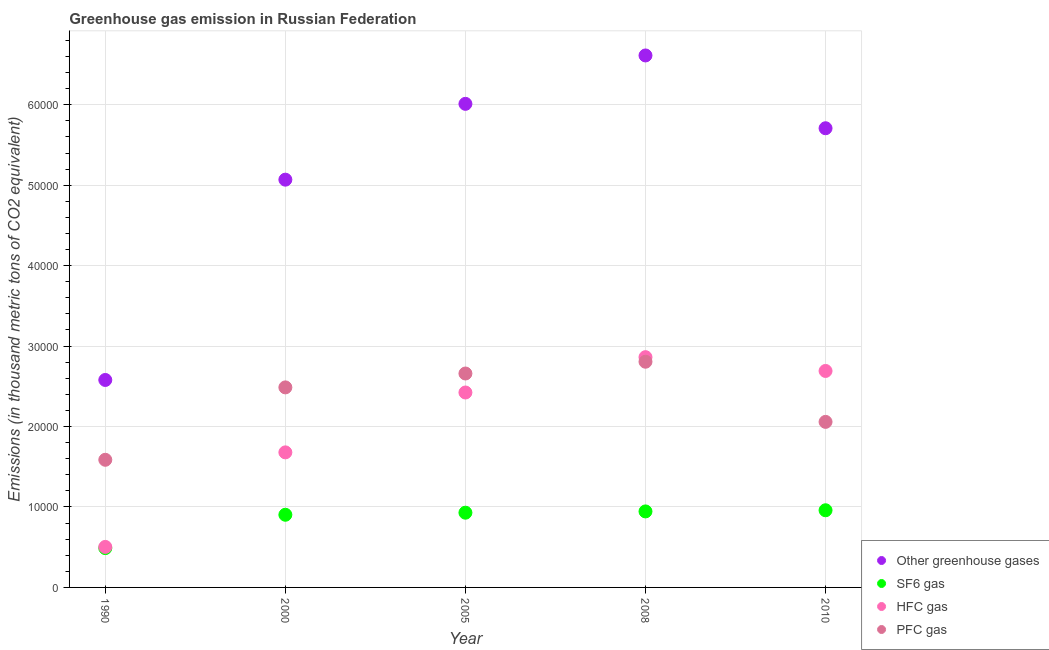Is the number of dotlines equal to the number of legend labels?
Your answer should be very brief. Yes. What is the emission of greenhouse gases in 2008?
Provide a short and direct response. 6.61e+04. Across all years, what is the maximum emission of pfc gas?
Your response must be concise. 2.81e+04. Across all years, what is the minimum emission of pfc gas?
Make the answer very short. 1.59e+04. In which year was the emission of pfc gas minimum?
Provide a succinct answer. 1990. What is the total emission of hfc gas in the graph?
Ensure brevity in your answer.  1.02e+05. What is the difference between the emission of hfc gas in 1990 and that in 2000?
Offer a terse response. -1.18e+04. What is the difference between the emission of greenhouse gases in 1990 and the emission of pfc gas in 2000?
Offer a very short reply. 922.5. What is the average emission of greenhouse gases per year?
Offer a very short reply. 5.20e+04. In the year 1990, what is the difference between the emission of sf6 gas and emission of pfc gas?
Ensure brevity in your answer.  -1.10e+04. In how many years, is the emission of pfc gas greater than 34000 thousand metric tons?
Your answer should be compact. 0. What is the ratio of the emission of greenhouse gases in 1990 to that in 2008?
Ensure brevity in your answer.  0.39. Is the difference between the emission of pfc gas in 2000 and 2010 greater than the difference between the emission of sf6 gas in 2000 and 2010?
Give a very brief answer. Yes. What is the difference between the highest and the second highest emission of hfc gas?
Keep it short and to the point. 1714.5. What is the difference between the highest and the lowest emission of hfc gas?
Ensure brevity in your answer.  2.36e+04. In how many years, is the emission of sf6 gas greater than the average emission of sf6 gas taken over all years?
Offer a very short reply. 4. Is it the case that in every year, the sum of the emission of greenhouse gases and emission of sf6 gas is greater than the emission of hfc gas?
Offer a very short reply. Yes. Is the emission of greenhouse gases strictly greater than the emission of pfc gas over the years?
Make the answer very short. Yes. How many dotlines are there?
Give a very brief answer. 4. How many years are there in the graph?
Make the answer very short. 5. What is the difference between two consecutive major ticks on the Y-axis?
Your response must be concise. 10000. Are the values on the major ticks of Y-axis written in scientific E-notation?
Keep it short and to the point. No. Does the graph contain grids?
Offer a very short reply. Yes. How many legend labels are there?
Your answer should be compact. 4. How are the legend labels stacked?
Keep it short and to the point. Vertical. What is the title of the graph?
Offer a terse response. Greenhouse gas emission in Russian Federation. Does "Secondary vocational" appear as one of the legend labels in the graph?
Make the answer very short. No. What is the label or title of the X-axis?
Keep it short and to the point. Year. What is the label or title of the Y-axis?
Give a very brief answer. Emissions (in thousand metric tons of CO2 equivalent). What is the Emissions (in thousand metric tons of CO2 equivalent) in Other greenhouse gases in 1990?
Give a very brief answer. 2.58e+04. What is the Emissions (in thousand metric tons of CO2 equivalent) in SF6 gas in 1990?
Provide a short and direct response. 4886.8. What is the Emissions (in thousand metric tons of CO2 equivalent) of HFC gas in 1990?
Provide a short and direct response. 5035.6. What is the Emissions (in thousand metric tons of CO2 equivalent) of PFC gas in 1990?
Offer a very short reply. 1.59e+04. What is the Emissions (in thousand metric tons of CO2 equivalent) in Other greenhouse gases in 2000?
Give a very brief answer. 5.07e+04. What is the Emissions (in thousand metric tons of CO2 equivalent) of SF6 gas in 2000?
Give a very brief answer. 9033.2. What is the Emissions (in thousand metric tons of CO2 equivalent) of HFC gas in 2000?
Make the answer very short. 1.68e+04. What is the Emissions (in thousand metric tons of CO2 equivalent) of PFC gas in 2000?
Offer a terse response. 2.49e+04. What is the Emissions (in thousand metric tons of CO2 equivalent) in Other greenhouse gases in 2005?
Your answer should be very brief. 6.01e+04. What is the Emissions (in thousand metric tons of CO2 equivalent) of SF6 gas in 2005?
Offer a terse response. 9289.9. What is the Emissions (in thousand metric tons of CO2 equivalent) in HFC gas in 2005?
Your answer should be very brief. 2.42e+04. What is the Emissions (in thousand metric tons of CO2 equivalent) in PFC gas in 2005?
Your answer should be compact. 2.66e+04. What is the Emissions (in thousand metric tons of CO2 equivalent) in Other greenhouse gases in 2008?
Provide a succinct answer. 6.61e+04. What is the Emissions (in thousand metric tons of CO2 equivalent) in SF6 gas in 2008?
Provide a short and direct response. 9448.2. What is the Emissions (in thousand metric tons of CO2 equivalent) of HFC gas in 2008?
Ensure brevity in your answer.  2.86e+04. What is the Emissions (in thousand metric tons of CO2 equivalent) in PFC gas in 2008?
Offer a terse response. 2.81e+04. What is the Emissions (in thousand metric tons of CO2 equivalent) of Other greenhouse gases in 2010?
Give a very brief answer. 5.71e+04. What is the Emissions (in thousand metric tons of CO2 equivalent) of SF6 gas in 2010?
Your response must be concise. 9592. What is the Emissions (in thousand metric tons of CO2 equivalent) in HFC gas in 2010?
Your answer should be very brief. 2.69e+04. What is the Emissions (in thousand metric tons of CO2 equivalent) in PFC gas in 2010?
Keep it short and to the point. 2.06e+04. Across all years, what is the maximum Emissions (in thousand metric tons of CO2 equivalent) in Other greenhouse gases?
Keep it short and to the point. 6.61e+04. Across all years, what is the maximum Emissions (in thousand metric tons of CO2 equivalent) in SF6 gas?
Your answer should be very brief. 9592. Across all years, what is the maximum Emissions (in thousand metric tons of CO2 equivalent) of HFC gas?
Give a very brief answer. 2.86e+04. Across all years, what is the maximum Emissions (in thousand metric tons of CO2 equivalent) in PFC gas?
Offer a terse response. 2.81e+04. Across all years, what is the minimum Emissions (in thousand metric tons of CO2 equivalent) of Other greenhouse gases?
Provide a short and direct response. 2.58e+04. Across all years, what is the minimum Emissions (in thousand metric tons of CO2 equivalent) of SF6 gas?
Provide a succinct answer. 4886.8. Across all years, what is the minimum Emissions (in thousand metric tons of CO2 equivalent) in HFC gas?
Offer a terse response. 5035.6. Across all years, what is the minimum Emissions (in thousand metric tons of CO2 equivalent) of PFC gas?
Make the answer very short. 1.59e+04. What is the total Emissions (in thousand metric tons of CO2 equivalent) in Other greenhouse gases in the graph?
Offer a terse response. 2.60e+05. What is the total Emissions (in thousand metric tons of CO2 equivalent) in SF6 gas in the graph?
Provide a short and direct response. 4.23e+04. What is the total Emissions (in thousand metric tons of CO2 equivalent) in HFC gas in the graph?
Ensure brevity in your answer.  1.02e+05. What is the total Emissions (in thousand metric tons of CO2 equivalent) in PFC gas in the graph?
Provide a short and direct response. 1.16e+05. What is the difference between the Emissions (in thousand metric tons of CO2 equivalent) of Other greenhouse gases in 1990 and that in 2000?
Ensure brevity in your answer.  -2.49e+04. What is the difference between the Emissions (in thousand metric tons of CO2 equivalent) in SF6 gas in 1990 and that in 2000?
Provide a succinct answer. -4146.4. What is the difference between the Emissions (in thousand metric tons of CO2 equivalent) of HFC gas in 1990 and that in 2000?
Ensure brevity in your answer.  -1.18e+04. What is the difference between the Emissions (in thousand metric tons of CO2 equivalent) of PFC gas in 1990 and that in 2000?
Your answer should be compact. -8999.9. What is the difference between the Emissions (in thousand metric tons of CO2 equivalent) of Other greenhouse gases in 1990 and that in 2005?
Keep it short and to the point. -3.43e+04. What is the difference between the Emissions (in thousand metric tons of CO2 equivalent) of SF6 gas in 1990 and that in 2005?
Provide a short and direct response. -4403.1. What is the difference between the Emissions (in thousand metric tons of CO2 equivalent) of HFC gas in 1990 and that in 2005?
Your answer should be compact. -1.92e+04. What is the difference between the Emissions (in thousand metric tons of CO2 equivalent) of PFC gas in 1990 and that in 2005?
Your response must be concise. -1.07e+04. What is the difference between the Emissions (in thousand metric tons of CO2 equivalent) of Other greenhouse gases in 1990 and that in 2008?
Make the answer very short. -4.03e+04. What is the difference between the Emissions (in thousand metric tons of CO2 equivalent) of SF6 gas in 1990 and that in 2008?
Ensure brevity in your answer.  -4561.4. What is the difference between the Emissions (in thousand metric tons of CO2 equivalent) of HFC gas in 1990 and that in 2008?
Offer a terse response. -2.36e+04. What is the difference between the Emissions (in thousand metric tons of CO2 equivalent) of PFC gas in 1990 and that in 2008?
Your answer should be compact. -1.22e+04. What is the difference between the Emissions (in thousand metric tons of CO2 equivalent) in Other greenhouse gases in 1990 and that in 2010?
Ensure brevity in your answer.  -3.13e+04. What is the difference between the Emissions (in thousand metric tons of CO2 equivalent) of SF6 gas in 1990 and that in 2010?
Your response must be concise. -4705.2. What is the difference between the Emissions (in thousand metric tons of CO2 equivalent) of HFC gas in 1990 and that in 2010?
Your answer should be compact. -2.19e+04. What is the difference between the Emissions (in thousand metric tons of CO2 equivalent) in PFC gas in 1990 and that in 2010?
Keep it short and to the point. -4711.8. What is the difference between the Emissions (in thousand metric tons of CO2 equivalent) in Other greenhouse gases in 2000 and that in 2005?
Your answer should be compact. -9424.5. What is the difference between the Emissions (in thousand metric tons of CO2 equivalent) in SF6 gas in 2000 and that in 2005?
Your answer should be very brief. -256.7. What is the difference between the Emissions (in thousand metric tons of CO2 equivalent) of HFC gas in 2000 and that in 2005?
Provide a succinct answer. -7442.6. What is the difference between the Emissions (in thousand metric tons of CO2 equivalent) of PFC gas in 2000 and that in 2005?
Your answer should be very brief. -1725.2. What is the difference between the Emissions (in thousand metric tons of CO2 equivalent) in Other greenhouse gases in 2000 and that in 2008?
Offer a very short reply. -1.54e+04. What is the difference between the Emissions (in thousand metric tons of CO2 equivalent) of SF6 gas in 2000 and that in 2008?
Your answer should be very brief. -415. What is the difference between the Emissions (in thousand metric tons of CO2 equivalent) in HFC gas in 2000 and that in 2008?
Provide a succinct answer. -1.18e+04. What is the difference between the Emissions (in thousand metric tons of CO2 equivalent) of PFC gas in 2000 and that in 2008?
Ensure brevity in your answer.  -3189.7. What is the difference between the Emissions (in thousand metric tons of CO2 equivalent) of Other greenhouse gases in 2000 and that in 2010?
Give a very brief answer. -6391. What is the difference between the Emissions (in thousand metric tons of CO2 equivalent) in SF6 gas in 2000 and that in 2010?
Offer a very short reply. -558.8. What is the difference between the Emissions (in thousand metric tons of CO2 equivalent) of HFC gas in 2000 and that in 2010?
Offer a terse response. -1.01e+04. What is the difference between the Emissions (in thousand metric tons of CO2 equivalent) in PFC gas in 2000 and that in 2010?
Provide a short and direct response. 4288.1. What is the difference between the Emissions (in thousand metric tons of CO2 equivalent) in Other greenhouse gases in 2005 and that in 2008?
Offer a terse response. -6015. What is the difference between the Emissions (in thousand metric tons of CO2 equivalent) in SF6 gas in 2005 and that in 2008?
Give a very brief answer. -158.3. What is the difference between the Emissions (in thousand metric tons of CO2 equivalent) in HFC gas in 2005 and that in 2008?
Offer a terse response. -4392.2. What is the difference between the Emissions (in thousand metric tons of CO2 equivalent) in PFC gas in 2005 and that in 2008?
Ensure brevity in your answer.  -1464.5. What is the difference between the Emissions (in thousand metric tons of CO2 equivalent) in Other greenhouse gases in 2005 and that in 2010?
Give a very brief answer. 3033.5. What is the difference between the Emissions (in thousand metric tons of CO2 equivalent) of SF6 gas in 2005 and that in 2010?
Make the answer very short. -302.1. What is the difference between the Emissions (in thousand metric tons of CO2 equivalent) in HFC gas in 2005 and that in 2010?
Your answer should be compact. -2677.7. What is the difference between the Emissions (in thousand metric tons of CO2 equivalent) in PFC gas in 2005 and that in 2010?
Give a very brief answer. 6013.3. What is the difference between the Emissions (in thousand metric tons of CO2 equivalent) of Other greenhouse gases in 2008 and that in 2010?
Your answer should be compact. 9048.5. What is the difference between the Emissions (in thousand metric tons of CO2 equivalent) of SF6 gas in 2008 and that in 2010?
Give a very brief answer. -143.8. What is the difference between the Emissions (in thousand metric tons of CO2 equivalent) of HFC gas in 2008 and that in 2010?
Provide a short and direct response. 1714.5. What is the difference between the Emissions (in thousand metric tons of CO2 equivalent) of PFC gas in 2008 and that in 2010?
Offer a very short reply. 7477.8. What is the difference between the Emissions (in thousand metric tons of CO2 equivalent) of Other greenhouse gases in 1990 and the Emissions (in thousand metric tons of CO2 equivalent) of SF6 gas in 2000?
Give a very brief answer. 1.68e+04. What is the difference between the Emissions (in thousand metric tons of CO2 equivalent) in Other greenhouse gases in 1990 and the Emissions (in thousand metric tons of CO2 equivalent) in HFC gas in 2000?
Make the answer very short. 8999.9. What is the difference between the Emissions (in thousand metric tons of CO2 equivalent) in Other greenhouse gases in 1990 and the Emissions (in thousand metric tons of CO2 equivalent) in PFC gas in 2000?
Ensure brevity in your answer.  922.5. What is the difference between the Emissions (in thousand metric tons of CO2 equivalent) in SF6 gas in 1990 and the Emissions (in thousand metric tons of CO2 equivalent) in HFC gas in 2000?
Offer a terse response. -1.19e+04. What is the difference between the Emissions (in thousand metric tons of CO2 equivalent) of SF6 gas in 1990 and the Emissions (in thousand metric tons of CO2 equivalent) of PFC gas in 2000?
Give a very brief answer. -2.00e+04. What is the difference between the Emissions (in thousand metric tons of CO2 equivalent) in HFC gas in 1990 and the Emissions (in thousand metric tons of CO2 equivalent) in PFC gas in 2000?
Ensure brevity in your answer.  -1.98e+04. What is the difference between the Emissions (in thousand metric tons of CO2 equivalent) of Other greenhouse gases in 1990 and the Emissions (in thousand metric tons of CO2 equivalent) of SF6 gas in 2005?
Ensure brevity in your answer.  1.65e+04. What is the difference between the Emissions (in thousand metric tons of CO2 equivalent) of Other greenhouse gases in 1990 and the Emissions (in thousand metric tons of CO2 equivalent) of HFC gas in 2005?
Give a very brief answer. 1557.3. What is the difference between the Emissions (in thousand metric tons of CO2 equivalent) in Other greenhouse gases in 1990 and the Emissions (in thousand metric tons of CO2 equivalent) in PFC gas in 2005?
Make the answer very short. -802.7. What is the difference between the Emissions (in thousand metric tons of CO2 equivalent) in SF6 gas in 1990 and the Emissions (in thousand metric tons of CO2 equivalent) in HFC gas in 2005?
Offer a very short reply. -1.93e+04. What is the difference between the Emissions (in thousand metric tons of CO2 equivalent) of SF6 gas in 1990 and the Emissions (in thousand metric tons of CO2 equivalent) of PFC gas in 2005?
Provide a short and direct response. -2.17e+04. What is the difference between the Emissions (in thousand metric tons of CO2 equivalent) in HFC gas in 1990 and the Emissions (in thousand metric tons of CO2 equivalent) in PFC gas in 2005?
Give a very brief answer. -2.16e+04. What is the difference between the Emissions (in thousand metric tons of CO2 equivalent) of Other greenhouse gases in 1990 and the Emissions (in thousand metric tons of CO2 equivalent) of SF6 gas in 2008?
Provide a succinct answer. 1.63e+04. What is the difference between the Emissions (in thousand metric tons of CO2 equivalent) of Other greenhouse gases in 1990 and the Emissions (in thousand metric tons of CO2 equivalent) of HFC gas in 2008?
Give a very brief answer. -2834.9. What is the difference between the Emissions (in thousand metric tons of CO2 equivalent) in Other greenhouse gases in 1990 and the Emissions (in thousand metric tons of CO2 equivalent) in PFC gas in 2008?
Keep it short and to the point. -2267.2. What is the difference between the Emissions (in thousand metric tons of CO2 equivalent) in SF6 gas in 1990 and the Emissions (in thousand metric tons of CO2 equivalent) in HFC gas in 2008?
Provide a succinct answer. -2.37e+04. What is the difference between the Emissions (in thousand metric tons of CO2 equivalent) of SF6 gas in 1990 and the Emissions (in thousand metric tons of CO2 equivalent) of PFC gas in 2008?
Make the answer very short. -2.32e+04. What is the difference between the Emissions (in thousand metric tons of CO2 equivalent) of HFC gas in 1990 and the Emissions (in thousand metric tons of CO2 equivalent) of PFC gas in 2008?
Ensure brevity in your answer.  -2.30e+04. What is the difference between the Emissions (in thousand metric tons of CO2 equivalent) of Other greenhouse gases in 1990 and the Emissions (in thousand metric tons of CO2 equivalent) of SF6 gas in 2010?
Ensure brevity in your answer.  1.62e+04. What is the difference between the Emissions (in thousand metric tons of CO2 equivalent) of Other greenhouse gases in 1990 and the Emissions (in thousand metric tons of CO2 equivalent) of HFC gas in 2010?
Your response must be concise. -1120.4. What is the difference between the Emissions (in thousand metric tons of CO2 equivalent) in Other greenhouse gases in 1990 and the Emissions (in thousand metric tons of CO2 equivalent) in PFC gas in 2010?
Ensure brevity in your answer.  5210.6. What is the difference between the Emissions (in thousand metric tons of CO2 equivalent) of SF6 gas in 1990 and the Emissions (in thousand metric tons of CO2 equivalent) of HFC gas in 2010?
Ensure brevity in your answer.  -2.20e+04. What is the difference between the Emissions (in thousand metric tons of CO2 equivalent) in SF6 gas in 1990 and the Emissions (in thousand metric tons of CO2 equivalent) in PFC gas in 2010?
Your answer should be very brief. -1.57e+04. What is the difference between the Emissions (in thousand metric tons of CO2 equivalent) in HFC gas in 1990 and the Emissions (in thousand metric tons of CO2 equivalent) in PFC gas in 2010?
Your answer should be compact. -1.55e+04. What is the difference between the Emissions (in thousand metric tons of CO2 equivalent) of Other greenhouse gases in 2000 and the Emissions (in thousand metric tons of CO2 equivalent) of SF6 gas in 2005?
Ensure brevity in your answer.  4.14e+04. What is the difference between the Emissions (in thousand metric tons of CO2 equivalent) in Other greenhouse gases in 2000 and the Emissions (in thousand metric tons of CO2 equivalent) in HFC gas in 2005?
Keep it short and to the point. 2.65e+04. What is the difference between the Emissions (in thousand metric tons of CO2 equivalent) in Other greenhouse gases in 2000 and the Emissions (in thousand metric tons of CO2 equivalent) in PFC gas in 2005?
Offer a very short reply. 2.41e+04. What is the difference between the Emissions (in thousand metric tons of CO2 equivalent) in SF6 gas in 2000 and the Emissions (in thousand metric tons of CO2 equivalent) in HFC gas in 2005?
Keep it short and to the point. -1.52e+04. What is the difference between the Emissions (in thousand metric tons of CO2 equivalent) of SF6 gas in 2000 and the Emissions (in thousand metric tons of CO2 equivalent) of PFC gas in 2005?
Your answer should be compact. -1.76e+04. What is the difference between the Emissions (in thousand metric tons of CO2 equivalent) of HFC gas in 2000 and the Emissions (in thousand metric tons of CO2 equivalent) of PFC gas in 2005?
Your response must be concise. -9802.6. What is the difference between the Emissions (in thousand metric tons of CO2 equivalent) of Other greenhouse gases in 2000 and the Emissions (in thousand metric tons of CO2 equivalent) of SF6 gas in 2008?
Provide a succinct answer. 4.12e+04. What is the difference between the Emissions (in thousand metric tons of CO2 equivalent) of Other greenhouse gases in 2000 and the Emissions (in thousand metric tons of CO2 equivalent) of HFC gas in 2008?
Make the answer very short. 2.21e+04. What is the difference between the Emissions (in thousand metric tons of CO2 equivalent) of Other greenhouse gases in 2000 and the Emissions (in thousand metric tons of CO2 equivalent) of PFC gas in 2008?
Keep it short and to the point. 2.26e+04. What is the difference between the Emissions (in thousand metric tons of CO2 equivalent) in SF6 gas in 2000 and the Emissions (in thousand metric tons of CO2 equivalent) in HFC gas in 2008?
Your answer should be compact. -1.96e+04. What is the difference between the Emissions (in thousand metric tons of CO2 equivalent) in SF6 gas in 2000 and the Emissions (in thousand metric tons of CO2 equivalent) in PFC gas in 2008?
Your answer should be compact. -1.90e+04. What is the difference between the Emissions (in thousand metric tons of CO2 equivalent) of HFC gas in 2000 and the Emissions (in thousand metric tons of CO2 equivalent) of PFC gas in 2008?
Offer a very short reply. -1.13e+04. What is the difference between the Emissions (in thousand metric tons of CO2 equivalent) of Other greenhouse gases in 2000 and the Emissions (in thousand metric tons of CO2 equivalent) of SF6 gas in 2010?
Your answer should be compact. 4.11e+04. What is the difference between the Emissions (in thousand metric tons of CO2 equivalent) of Other greenhouse gases in 2000 and the Emissions (in thousand metric tons of CO2 equivalent) of HFC gas in 2010?
Offer a terse response. 2.38e+04. What is the difference between the Emissions (in thousand metric tons of CO2 equivalent) of Other greenhouse gases in 2000 and the Emissions (in thousand metric tons of CO2 equivalent) of PFC gas in 2010?
Provide a short and direct response. 3.01e+04. What is the difference between the Emissions (in thousand metric tons of CO2 equivalent) in SF6 gas in 2000 and the Emissions (in thousand metric tons of CO2 equivalent) in HFC gas in 2010?
Provide a short and direct response. -1.79e+04. What is the difference between the Emissions (in thousand metric tons of CO2 equivalent) in SF6 gas in 2000 and the Emissions (in thousand metric tons of CO2 equivalent) in PFC gas in 2010?
Your answer should be very brief. -1.15e+04. What is the difference between the Emissions (in thousand metric tons of CO2 equivalent) in HFC gas in 2000 and the Emissions (in thousand metric tons of CO2 equivalent) in PFC gas in 2010?
Your response must be concise. -3789.3. What is the difference between the Emissions (in thousand metric tons of CO2 equivalent) of Other greenhouse gases in 2005 and the Emissions (in thousand metric tons of CO2 equivalent) of SF6 gas in 2008?
Give a very brief answer. 5.07e+04. What is the difference between the Emissions (in thousand metric tons of CO2 equivalent) of Other greenhouse gases in 2005 and the Emissions (in thousand metric tons of CO2 equivalent) of HFC gas in 2008?
Ensure brevity in your answer.  3.15e+04. What is the difference between the Emissions (in thousand metric tons of CO2 equivalent) in Other greenhouse gases in 2005 and the Emissions (in thousand metric tons of CO2 equivalent) in PFC gas in 2008?
Keep it short and to the point. 3.21e+04. What is the difference between the Emissions (in thousand metric tons of CO2 equivalent) in SF6 gas in 2005 and the Emissions (in thousand metric tons of CO2 equivalent) in HFC gas in 2008?
Give a very brief answer. -1.93e+04. What is the difference between the Emissions (in thousand metric tons of CO2 equivalent) of SF6 gas in 2005 and the Emissions (in thousand metric tons of CO2 equivalent) of PFC gas in 2008?
Your answer should be compact. -1.88e+04. What is the difference between the Emissions (in thousand metric tons of CO2 equivalent) in HFC gas in 2005 and the Emissions (in thousand metric tons of CO2 equivalent) in PFC gas in 2008?
Ensure brevity in your answer.  -3824.5. What is the difference between the Emissions (in thousand metric tons of CO2 equivalent) of Other greenhouse gases in 2005 and the Emissions (in thousand metric tons of CO2 equivalent) of SF6 gas in 2010?
Offer a very short reply. 5.05e+04. What is the difference between the Emissions (in thousand metric tons of CO2 equivalent) in Other greenhouse gases in 2005 and the Emissions (in thousand metric tons of CO2 equivalent) in HFC gas in 2010?
Your answer should be very brief. 3.32e+04. What is the difference between the Emissions (in thousand metric tons of CO2 equivalent) of Other greenhouse gases in 2005 and the Emissions (in thousand metric tons of CO2 equivalent) of PFC gas in 2010?
Your answer should be very brief. 3.95e+04. What is the difference between the Emissions (in thousand metric tons of CO2 equivalent) of SF6 gas in 2005 and the Emissions (in thousand metric tons of CO2 equivalent) of HFC gas in 2010?
Ensure brevity in your answer.  -1.76e+04. What is the difference between the Emissions (in thousand metric tons of CO2 equivalent) in SF6 gas in 2005 and the Emissions (in thousand metric tons of CO2 equivalent) in PFC gas in 2010?
Offer a terse response. -1.13e+04. What is the difference between the Emissions (in thousand metric tons of CO2 equivalent) of HFC gas in 2005 and the Emissions (in thousand metric tons of CO2 equivalent) of PFC gas in 2010?
Offer a very short reply. 3653.3. What is the difference between the Emissions (in thousand metric tons of CO2 equivalent) of Other greenhouse gases in 2008 and the Emissions (in thousand metric tons of CO2 equivalent) of SF6 gas in 2010?
Your response must be concise. 5.65e+04. What is the difference between the Emissions (in thousand metric tons of CO2 equivalent) in Other greenhouse gases in 2008 and the Emissions (in thousand metric tons of CO2 equivalent) in HFC gas in 2010?
Ensure brevity in your answer.  3.92e+04. What is the difference between the Emissions (in thousand metric tons of CO2 equivalent) in Other greenhouse gases in 2008 and the Emissions (in thousand metric tons of CO2 equivalent) in PFC gas in 2010?
Your answer should be compact. 4.55e+04. What is the difference between the Emissions (in thousand metric tons of CO2 equivalent) in SF6 gas in 2008 and the Emissions (in thousand metric tons of CO2 equivalent) in HFC gas in 2010?
Give a very brief answer. -1.75e+04. What is the difference between the Emissions (in thousand metric tons of CO2 equivalent) in SF6 gas in 2008 and the Emissions (in thousand metric tons of CO2 equivalent) in PFC gas in 2010?
Make the answer very short. -1.11e+04. What is the difference between the Emissions (in thousand metric tons of CO2 equivalent) of HFC gas in 2008 and the Emissions (in thousand metric tons of CO2 equivalent) of PFC gas in 2010?
Offer a very short reply. 8045.5. What is the average Emissions (in thousand metric tons of CO2 equivalent) in Other greenhouse gases per year?
Give a very brief answer. 5.20e+04. What is the average Emissions (in thousand metric tons of CO2 equivalent) of SF6 gas per year?
Provide a succinct answer. 8450.02. What is the average Emissions (in thousand metric tons of CO2 equivalent) of HFC gas per year?
Ensure brevity in your answer.  2.03e+04. What is the average Emissions (in thousand metric tons of CO2 equivalent) in PFC gas per year?
Provide a succinct answer. 2.32e+04. In the year 1990, what is the difference between the Emissions (in thousand metric tons of CO2 equivalent) in Other greenhouse gases and Emissions (in thousand metric tons of CO2 equivalent) in SF6 gas?
Ensure brevity in your answer.  2.09e+04. In the year 1990, what is the difference between the Emissions (in thousand metric tons of CO2 equivalent) of Other greenhouse gases and Emissions (in thousand metric tons of CO2 equivalent) of HFC gas?
Provide a short and direct response. 2.08e+04. In the year 1990, what is the difference between the Emissions (in thousand metric tons of CO2 equivalent) in Other greenhouse gases and Emissions (in thousand metric tons of CO2 equivalent) in PFC gas?
Provide a short and direct response. 9922.4. In the year 1990, what is the difference between the Emissions (in thousand metric tons of CO2 equivalent) in SF6 gas and Emissions (in thousand metric tons of CO2 equivalent) in HFC gas?
Provide a succinct answer. -148.8. In the year 1990, what is the difference between the Emissions (in thousand metric tons of CO2 equivalent) of SF6 gas and Emissions (in thousand metric tons of CO2 equivalent) of PFC gas?
Offer a very short reply. -1.10e+04. In the year 1990, what is the difference between the Emissions (in thousand metric tons of CO2 equivalent) of HFC gas and Emissions (in thousand metric tons of CO2 equivalent) of PFC gas?
Give a very brief answer. -1.08e+04. In the year 2000, what is the difference between the Emissions (in thousand metric tons of CO2 equivalent) of Other greenhouse gases and Emissions (in thousand metric tons of CO2 equivalent) of SF6 gas?
Your answer should be very brief. 4.17e+04. In the year 2000, what is the difference between the Emissions (in thousand metric tons of CO2 equivalent) in Other greenhouse gases and Emissions (in thousand metric tons of CO2 equivalent) in HFC gas?
Your answer should be very brief. 3.39e+04. In the year 2000, what is the difference between the Emissions (in thousand metric tons of CO2 equivalent) in Other greenhouse gases and Emissions (in thousand metric tons of CO2 equivalent) in PFC gas?
Keep it short and to the point. 2.58e+04. In the year 2000, what is the difference between the Emissions (in thousand metric tons of CO2 equivalent) of SF6 gas and Emissions (in thousand metric tons of CO2 equivalent) of HFC gas?
Make the answer very short. -7755.5. In the year 2000, what is the difference between the Emissions (in thousand metric tons of CO2 equivalent) of SF6 gas and Emissions (in thousand metric tons of CO2 equivalent) of PFC gas?
Provide a succinct answer. -1.58e+04. In the year 2000, what is the difference between the Emissions (in thousand metric tons of CO2 equivalent) of HFC gas and Emissions (in thousand metric tons of CO2 equivalent) of PFC gas?
Offer a terse response. -8077.4. In the year 2005, what is the difference between the Emissions (in thousand metric tons of CO2 equivalent) in Other greenhouse gases and Emissions (in thousand metric tons of CO2 equivalent) in SF6 gas?
Keep it short and to the point. 5.08e+04. In the year 2005, what is the difference between the Emissions (in thousand metric tons of CO2 equivalent) of Other greenhouse gases and Emissions (in thousand metric tons of CO2 equivalent) of HFC gas?
Your response must be concise. 3.59e+04. In the year 2005, what is the difference between the Emissions (in thousand metric tons of CO2 equivalent) in Other greenhouse gases and Emissions (in thousand metric tons of CO2 equivalent) in PFC gas?
Make the answer very short. 3.35e+04. In the year 2005, what is the difference between the Emissions (in thousand metric tons of CO2 equivalent) of SF6 gas and Emissions (in thousand metric tons of CO2 equivalent) of HFC gas?
Give a very brief answer. -1.49e+04. In the year 2005, what is the difference between the Emissions (in thousand metric tons of CO2 equivalent) of SF6 gas and Emissions (in thousand metric tons of CO2 equivalent) of PFC gas?
Give a very brief answer. -1.73e+04. In the year 2005, what is the difference between the Emissions (in thousand metric tons of CO2 equivalent) of HFC gas and Emissions (in thousand metric tons of CO2 equivalent) of PFC gas?
Ensure brevity in your answer.  -2360. In the year 2008, what is the difference between the Emissions (in thousand metric tons of CO2 equivalent) of Other greenhouse gases and Emissions (in thousand metric tons of CO2 equivalent) of SF6 gas?
Keep it short and to the point. 5.67e+04. In the year 2008, what is the difference between the Emissions (in thousand metric tons of CO2 equivalent) in Other greenhouse gases and Emissions (in thousand metric tons of CO2 equivalent) in HFC gas?
Give a very brief answer. 3.75e+04. In the year 2008, what is the difference between the Emissions (in thousand metric tons of CO2 equivalent) of Other greenhouse gases and Emissions (in thousand metric tons of CO2 equivalent) of PFC gas?
Keep it short and to the point. 3.81e+04. In the year 2008, what is the difference between the Emissions (in thousand metric tons of CO2 equivalent) in SF6 gas and Emissions (in thousand metric tons of CO2 equivalent) in HFC gas?
Your answer should be compact. -1.92e+04. In the year 2008, what is the difference between the Emissions (in thousand metric tons of CO2 equivalent) in SF6 gas and Emissions (in thousand metric tons of CO2 equivalent) in PFC gas?
Provide a short and direct response. -1.86e+04. In the year 2008, what is the difference between the Emissions (in thousand metric tons of CO2 equivalent) in HFC gas and Emissions (in thousand metric tons of CO2 equivalent) in PFC gas?
Offer a terse response. 567.7. In the year 2010, what is the difference between the Emissions (in thousand metric tons of CO2 equivalent) of Other greenhouse gases and Emissions (in thousand metric tons of CO2 equivalent) of SF6 gas?
Your answer should be compact. 4.75e+04. In the year 2010, what is the difference between the Emissions (in thousand metric tons of CO2 equivalent) of Other greenhouse gases and Emissions (in thousand metric tons of CO2 equivalent) of HFC gas?
Offer a terse response. 3.02e+04. In the year 2010, what is the difference between the Emissions (in thousand metric tons of CO2 equivalent) of Other greenhouse gases and Emissions (in thousand metric tons of CO2 equivalent) of PFC gas?
Your response must be concise. 3.65e+04. In the year 2010, what is the difference between the Emissions (in thousand metric tons of CO2 equivalent) of SF6 gas and Emissions (in thousand metric tons of CO2 equivalent) of HFC gas?
Give a very brief answer. -1.73e+04. In the year 2010, what is the difference between the Emissions (in thousand metric tons of CO2 equivalent) in SF6 gas and Emissions (in thousand metric tons of CO2 equivalent) in PFC gas?
Offer a terse response. -1.10e+04. In the year 2010, what is the difference between the Emissions (in thousand metric tons of CO2 equivalent) in HFC gas and Emissions (in thousand metric tons of CO2 equivalent) in PFC gas?
Make the answer very short. 6331. What is the ratio of the Emissions (in thousand metric tons of CO2 equivalent) in Other greenhouse gases in 1990 to that in 2000?
Offer a very short reply. 0.51. What is the ratio of the Emissions (in thousand metric tons of CO2 equivalent) in SF6 gas in 1990 to that in 2000?
Offer a very short reply. 0.54. What is the ratio of the Emissions (in thousand metric tons of CO2 equivalent) in HFC gas in 1990 to that in 2000?
Ensure brevity in your answer.  0.3. What is the ratio of the Emissions (in thousand metric tons of CO2 equivalent) of PFC gas in 1990 to that in 2000?
Your answer should be compact. 0.64. What is the ratio of the Emissions (in thousand metric tons of CO2 equivalent) of Other greenhouse gases in 1990 to that in 2005?
Give a very brief answer. 0.43. What is the ratio of the Emissions (in thousand metric tons of CO2 equivalent) of SF6 gas in 1990 to that in 2005?
Offer a very short reply. 0.53. What is the ratio of the Emissions (in thousand metric tons of CO2 equivalent) of HFC gas in 1990 to that in 2005?
Offer a terse response. 0.21. What is the ratio of the Emissions (in thousand metric tons of CO2 equivalent) in PFC gas in 1990 to that in 2005?
Provide a succinct answer. 0.6. What is the ratio of the Emissions (in thousand metric tons of CO2 equivalent) in Other greenhouse gases in 1990 to that in 2008?
Give a very brief answer. 0.39. What is the ratio of the Emissions (in thousand metric tons of CO2 equivalent) of SF6 gas in 1990 to that in 2008?
Your response must be concise. 0.52. What is the ratio of the Emissions (in thousand metric tons of CO2 equivalent) in HFC gas in 1990 to that in 2008?
Offer a terse response. 0.18. What is the ratio of the Emissions (in thousand metric tons of CO2 equivalent) in PFC gas in 1990 to that in 2008?
Your answer should be compact. 0.57. What is the ratio of the Emissions (in thousand metric tons of CO2 equivalent) of Other greenhouse gases in 1990 to that in 2010?
Your answer should be compact. 0.45. What is the ratio of the Emissions (in thousand metric tons of CO2 equivalent) of SF6 gas in 1990 to that in 2010?
Offer a terse response. 0.51. What is the ratio of the Emissions (in thousand metric tons of CO2 equivalent) in HFC gas in 1990 to that in 2010?
Ensure brevity in your answer.  0.19. What is the ratio of the Emissions (in thousand metric tons of CO2 equivalent) in PFC gas in 1990 to that in 2010?
Offer a very short reply. 0.77. What is the ratio of the Emissions (in thousand metric tons of CO2 equivalent) of Other greenhouse gases in 2000 to that in 2005?
Give a very brief answer. 0.84. What is the ratio of the Emissions (in thousand metric tons of CO2 equivalent) in SF6 gas in 2000 to that in 2005?
Your answer should be very brief. 0.97. What is the ratio of the Emissions (in thousand metric tons of CO2 equivalent) in HFC gas in 2000 to that in 2005?
Offer a terse response. 0.69. What is the ratio of the Emissions (in thousand metric tons of CO2 equivalent) in PFC gas in 2000 to that in 2005?
Your answer should be compact. 0.94. What is the ratio of the Emissions (in thousand metric tons of CO2 equivalent) in Other greenhouse gases in 2000 to that in 2008?
Provide a succinct answer. 0.77. What is the ratio of the Emissions (in thousand metric tons of CO2 equivalent) in SF6 gas in 2000 to that in 2008?
Your answer should be compact. 0.96. What is the ratio of the Emissions (in thousand metric tons of CO2 equivalent) of HFC gas in 2000 to that in 2008?
Provide a succinct answer. 0.59. What is the ratio of the Emissions (in thousand metric tons of CO2 equivalent) of PFC gas in 2000 to that in 2008?
Provide a succinct answer. 0.89. What is the ratio of the Emissions (in thousand metric tons of CO2 equivalent) of Other greenhouse gases in 2000 to that in 2010?
Offer a very short reply. 0.89. What is the ratio of the Emissions (in thousand metric tons of CO2 equivalent) of SF6 gas in 2000 to that in 2010?
Ensure brevity in your answer.  0.94. What is the ratio of the Emissions (in thousand metric tons of CO2 equivalent) in HFC gas in 2000 to that in 2010?
Offer a very short reply. 0.62. What is the ratio of the Emissions (in thousand metric tons of CO2 equivalent) of PFC gas in 2000 to that in 2010?
Give a very brief answer. 1.21. What is the ratio of the Emissions (in thousand metric tons of CO2 equivalent) of Other greenhouse gases in 2005 to that in 2008?
Your response must be concise. 0.91. What is the ratio of the Emissions (in thousand metric tons of CO2 equivalent) of SF6 gas in 2005 to that in 2008?
Provide a succinct answer. 0.98. What is the ratio of the Emissions (in thousand metric tons of CO2 equivalent) of HFC gas in 2005 to that in 2008?
Give a very brief answer. 0.85. What is the ratio of the Emissions (in thousand metric tons of CO2 equivalent) in PFC gas in 2005 to that in 2008?
Provide a succinct answer. 0.95. What is the ratio of the Emissions (in thousand metric tons of CO2 equivalent) in Other greenhouse gases in 2005 to that in 2010?
Your answer should be compact. 1.05. What is the ratio of the Emissions (in thousand metric tons of CO2 equivalent) in SF6 gas in 2005 to that in 2010?
Offer a terse response. 0.97. What is the ratio of the Emissions (in thousand metric tons of CO2 equivalent) of HFC gas in 2005 to that in 2010?
Your response must be concise. 0.9. What is the ratio of the Emissions (in thousand metric tons of CO2 equivalent) in PFC gas in 2005 to that in 2010?
Ensure brevity in your answer.  1.29. What is the ratio of the Emissions (in thousand metric tons of CO2 equivalent) in Other greenhouse gases in 2008 to that in 2010?
Give a very brief answer. 1.16. What is the ratio of the Emissions (in thousand metric tons of CO2 equivalent) in HFC gas in 2008 to that in 2010?
Offer a very short reply. 1.06. What is the ratio of the Emissions (in thousand metric tons of CO2 equivalent) of PFC gas in 2008 to that in 2010?
Your response must be concise. 1.36. What is the difference between the highest and the second highest Emissions (in thousand metric tons of CO2 equivalent) of Other greenhouse gases?
Your answer should be compact. 6015. What is the difference between the highest and the second highest Emissions (in thousand metric tons of CO2 equivalent) of SF6 gas?
Your response must be concise. 143.8. What is the difference between the highest and the second highest Emissions (in thousand metric tons of CO2 equivalent) in HFC gas?
Make the answer very short. 1714.5. What is the difference between the highest and the second highest Emissions (in thousand metric tons of CO2 equivalent) in PFC gas?
Give a very brief answer. 1464.5. What is the difference between the highest and the lowest Emissions (in thousand metric tons of CO2 equivalent) of Other greenhouse gases?
Ensure brevity in your answer.  4.03e+04. What is the difference between the highest and the lowest Emissions (in thousand metric tons of CO2 equivalent) of SF6 gas?
Offer a terse response. 4705.2. What is the difference between the highest and the lowest Emissions (in thousand metric tons of CO2 equivalent) of HFC gas?
Your answer should be compact. 2.36e+04. What is the difference between the highest and the lowest Emissions (in thousand metric tons of CO2 equivalent) in PFC gas?
Offer a very short reply. 1.22e+04. 